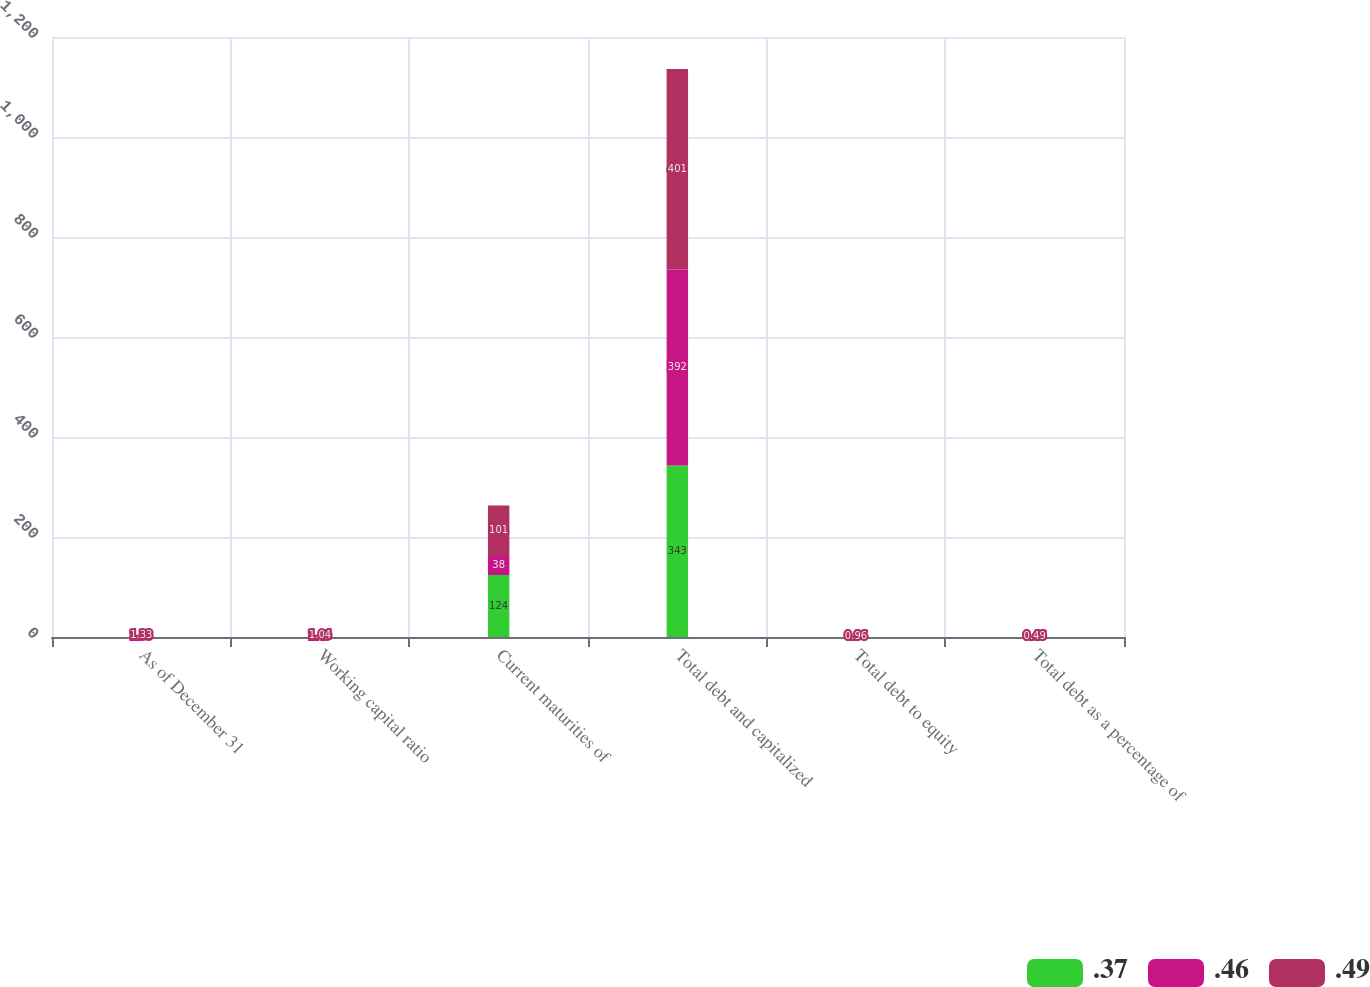Convert chart. <chart><loc_0><loc_0><loc_500><loc_500><stacked_bar_chart><ecel><fcel>As of December 31<fcel>Working capital ratio<fcel>Current maturities of<fcel>Total debt and capitalized<fcel>Total debt to equity<fcel>Total debt as a percentage of<nl><fcel>0.37<fcel>1.33<fcel>1.33<fcel>124<fcel>343<fcel>0.58<fcel>0.37<nl><fcel>0.46<fcel>1.33<fcel>1.45<fcel>38<fcel>392<fcel>0.86<fcel>0.46<nl><fcel>0.49<fcel>1.33<fcel>1.04<fcel>101<fcel>401<fcel>0.96<fcel>0.49<nl></chart> 